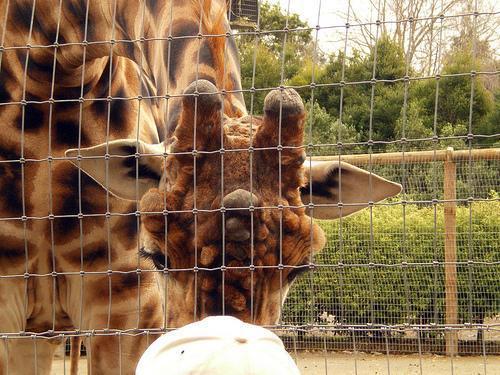How many giraffes are there?
Give a very brief answer. 1. 